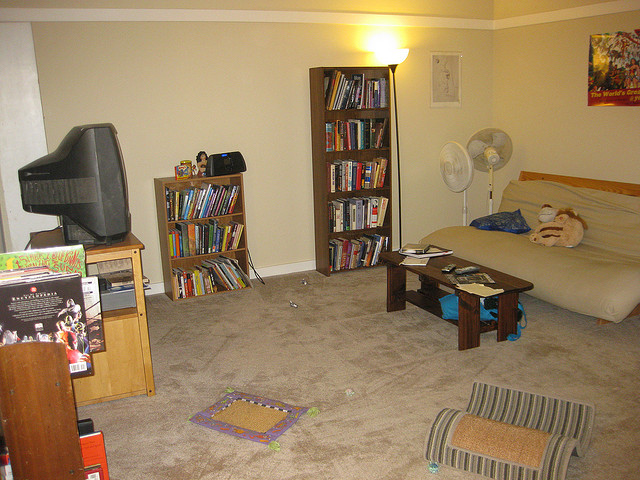<image>What words are on the poster on the wall above the bed? It's unknown what words are on the poster on the wall above the bed, it could be "world's greatest", "live love laugh", "wizards curse" or "music". What words are on the poster on the wall above the bed? I am not sure what words are on the poster on the wall above the bed. It can be seen "world's greatest", "live love laugh", "wizards curse", or "music". 